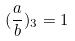Convert formula to latex. <formula><loc_0><loc_0><loc_500><loc_500>( \frac { a } { b } ) _ { 3 } = 1</formula> 